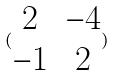Convert formula to latex. <formula><loc_0><loc_0><loc_500><loc_500>( \begin{matrix} 2 & - 4 \\ - 1 & 2 \end{matrix} )</formula> 